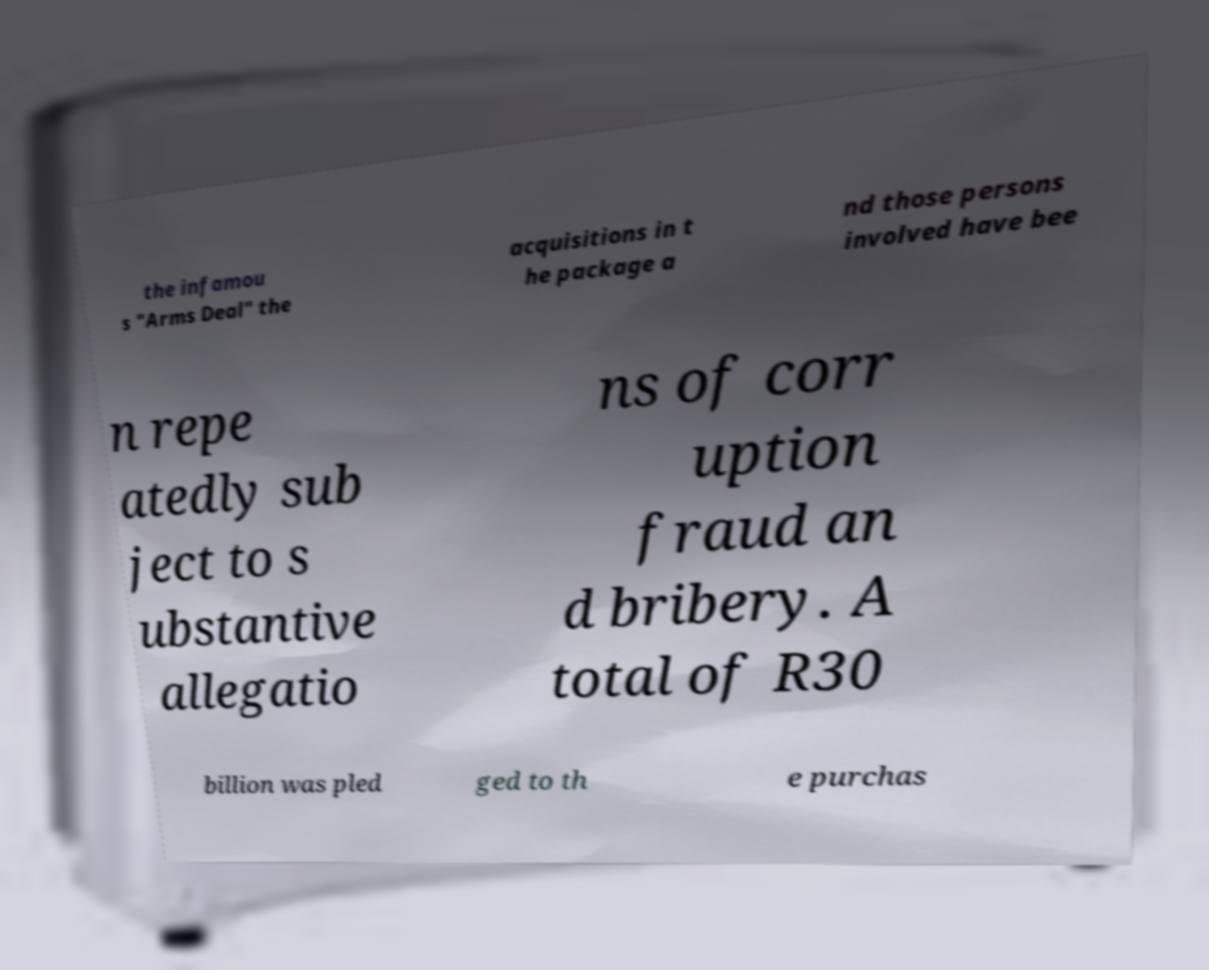Please read and relay the text visible in this image. What does it say? the infamou s "Arms Deal" the acquisitions in t he package a nd those persons involved have bee n repe atedly sub ject to s ubstantive allegatio ns of corr uption fraud an d bribery. A total of R30 billion was pled ged to th e purchas 